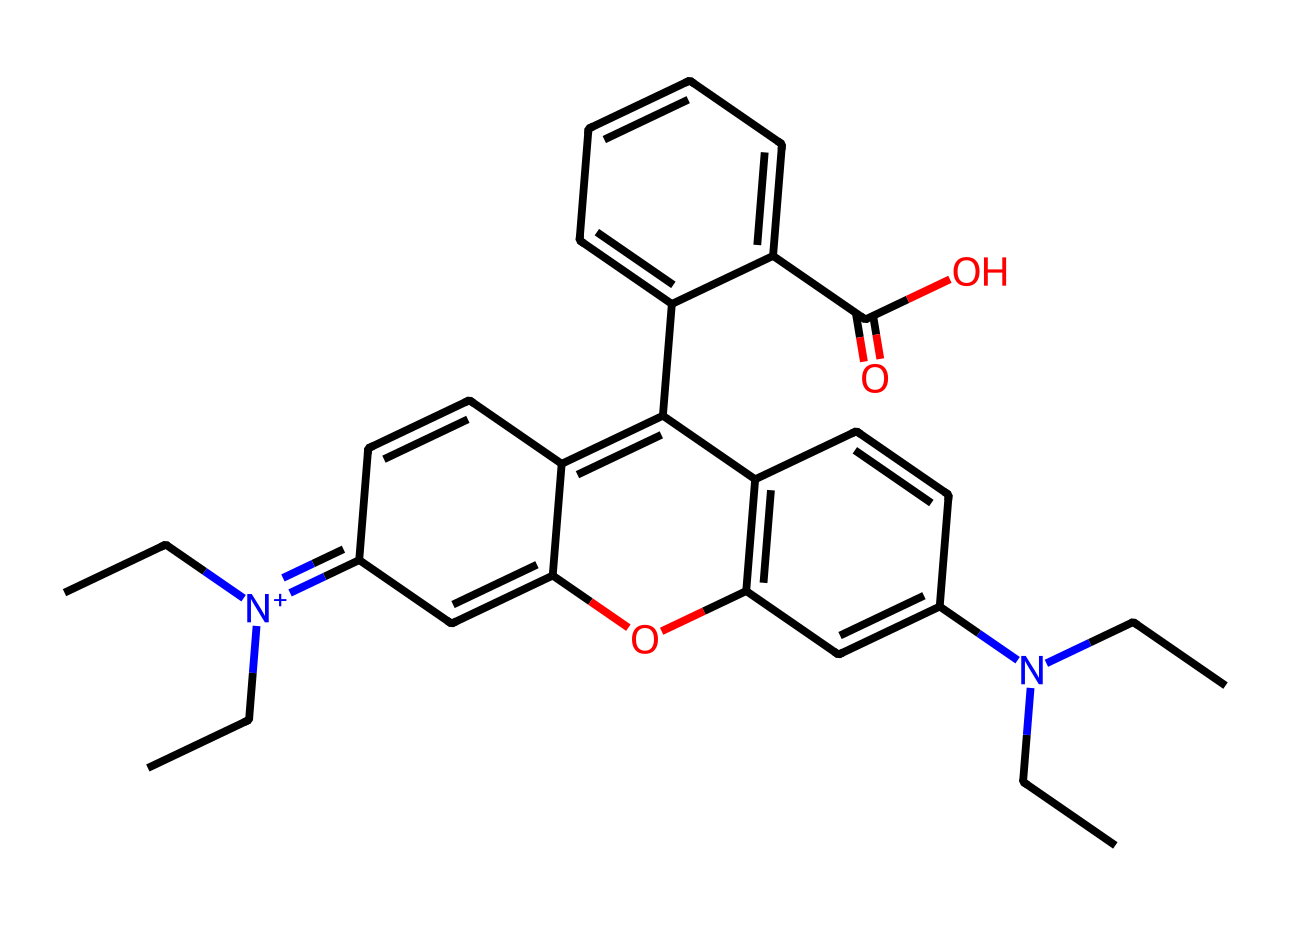What is the molecular formula of rhodamine B? By analyzing the structure represented by the SMILES notation, we count the elements: 6 carbon (C) atoms from the rings and chains, 6 carbon (C) atoms from additional substituents, 1 nitrogen (N) atom (from the positively charged nitrogen), 2 oxygen (O) atoms, and 3 hydrogen (H) atoms. So, the total number of atoms translates to a molecular formula of C28H31N2O3.
Answer: C28H31N2O3 How many nitrogen atoms are present in the structure? Looking closely at the SMILES representation, there is one nitrogen atom (N) indicated by the notation [N+]. Thus, the count of nitrogen atoms is easy to determine as just one.
Answer: 1 What functional groups are present in rhodamine B? From the structure shown in the SMILES, we can identify a carboxylic acid (-COOH) from the terminal C(=O)O and a hydroxyl group (-OH) attached to the aromatic system. Additionally, the presence of a quaternary ammonium group from the nitrogen atom indicates further functionalization. Hence, we can outline the primary functional groups: hydroxyl, carboxylic acid, and quaternary ammonium.
Answer: hydroxyl, carboxylic acid, quaternary ammonium What is the total number of rings in the rhodamine B structure? By analyzing the structure as described in the SMILES notation, we can identify that there are four distinct ring structures present. This is observed through the connections and the cyclic nature of the carbon atoms present.
Answer: 4 What property allows rhodamine B to be used as a fluorescent dye? Rhodamine B contains an aromatic structure, which effectively conjugates pi systems; this conjugation allows the molecule to absorb light at certain wavelengths and re-emit it in longer wavelengths when excited, thus exhibiting fluorescence. The presence of extended conjugation is key to its fluorescent properties.
Answer: extended conjugation What is the major structural feature of rhodamine B that contributes to its color? The extensive conjugated double bonds in the structure, particularly within the phenyl rings, lead to significant electronic transitions that absorb visible light, hence determining the dye's color. The interaction of these bonds with light directly correlates with the observed appearance.
Answer: conjugated double bonds 